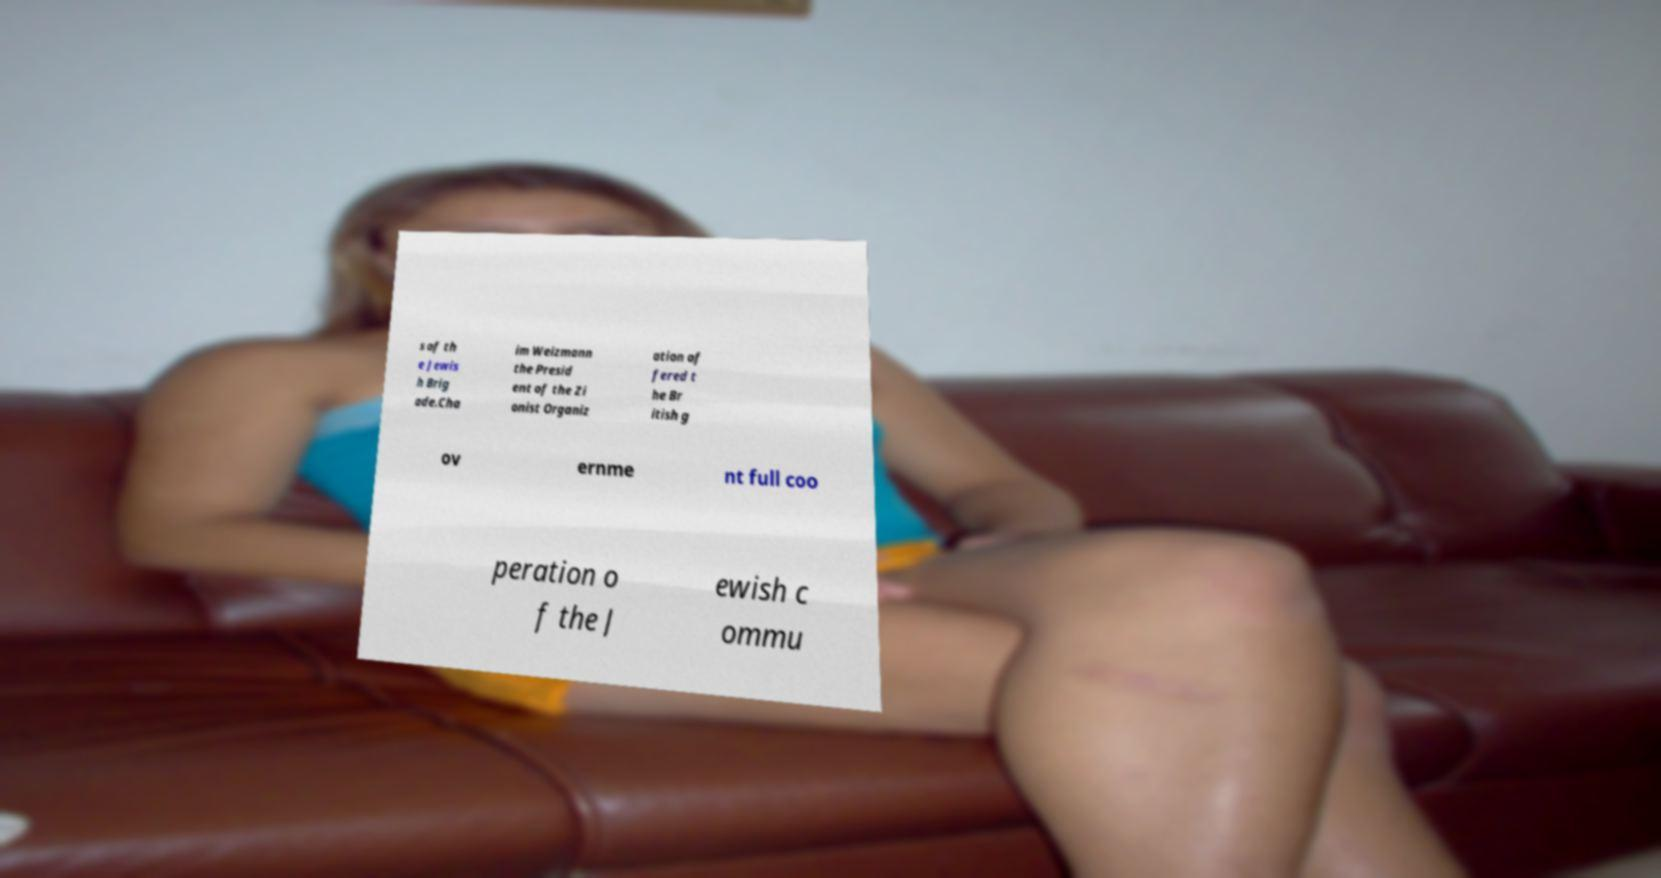What messages or text are displayed in this image? I need them in a readable, typed format. s of th e Jewis h Brig ade.Cha im Weizmann the Presid ent of the Zi onist Organiz ation of fered t he Br itish g ov ernme nt full coo peration o f the J ewish c ommu 